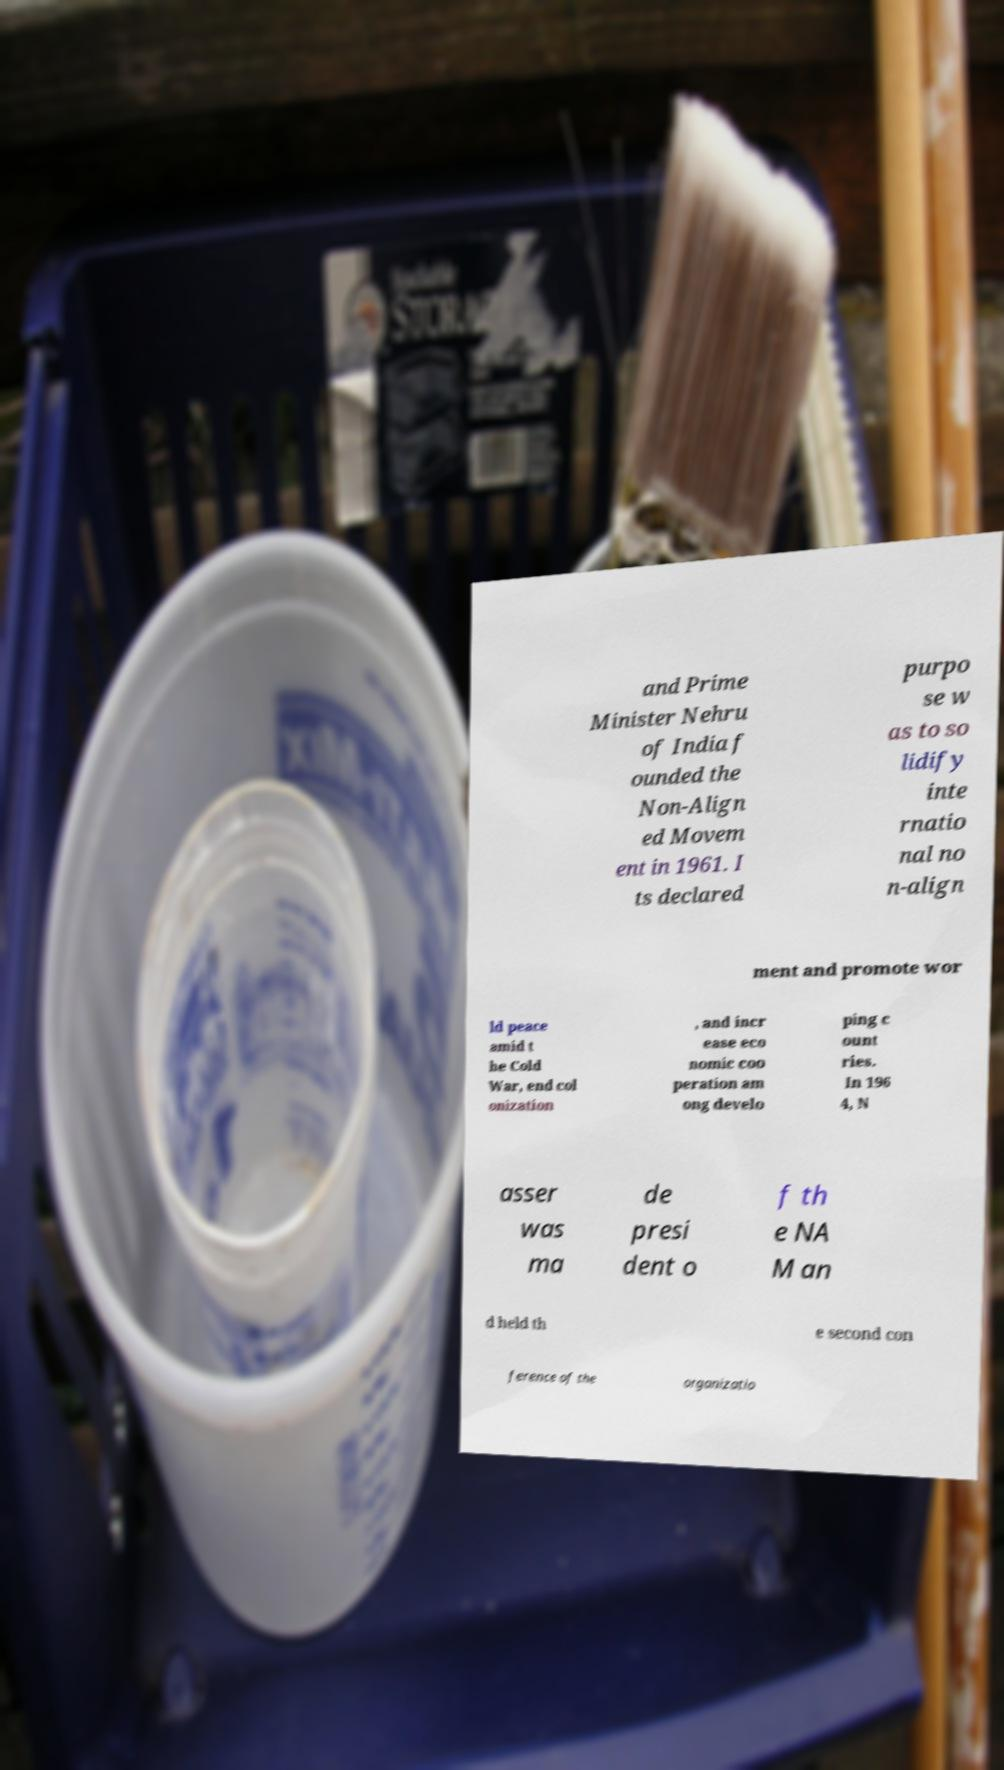For documentation purposes, I need the text within this image transcribed. Could you provide that? and Prime Minister Nehru of India f ounded the Non-Align ed Movem ent in 1961. I ts declared purpo se w as to so lidify inte rnatio nal no n-align ment and promote wor ld peace amid t he Cold War, end col onization , and incr ease eco nomic coo peration am ong develo ping c ount ries. In 196 4, N asser was ma de presi dent o f th e NA M an d held th e second con ference of the organizatio 